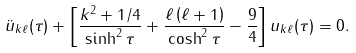Convert formula to latex. <formula><loc_0><loc_0><loc_500><loc_500>\ddot { u } _ { k \ell } ( \tau ) + \left [ \frac { k ^ { 2 } + 1 / 4 } { \sinh ^ { 2 } \tau } + \frac { \ell \left ( \ell + 1 \right ) } { \cosh ^ { 2 } \tau } - \frac { 9 } { 4 } \right ] u _ { k \ell } ( \tau ) = 0 .</formula> 